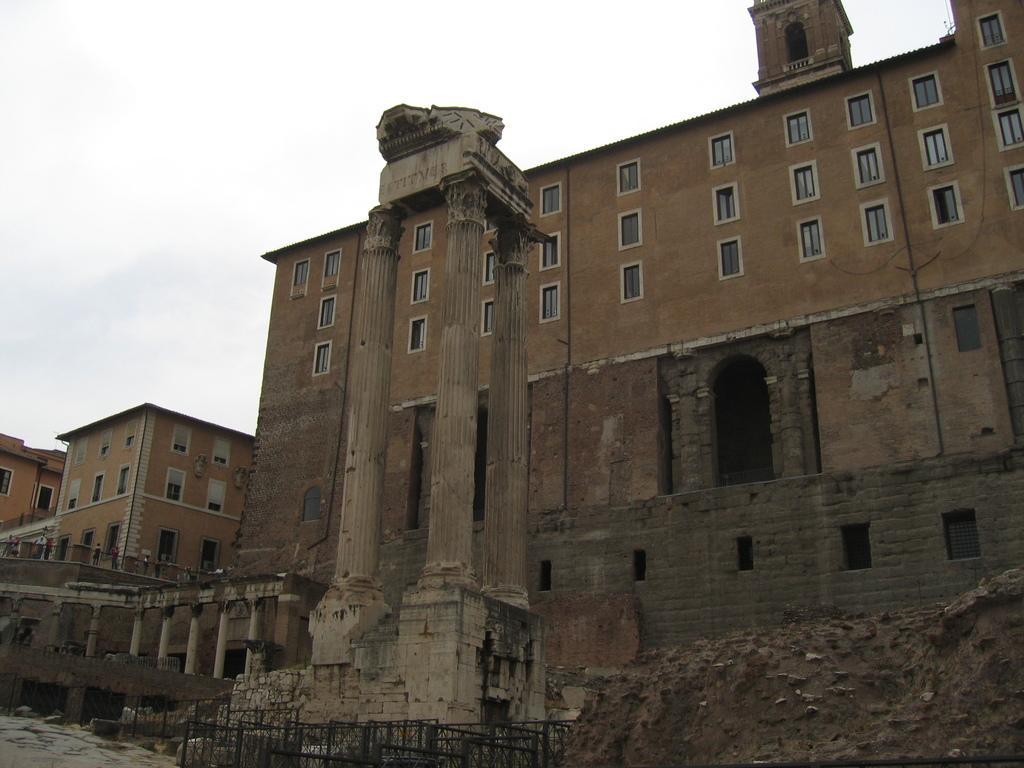Could you give a brief overview of what you see in this image? In the center of the image we can see buildings, pillars, wall, fencing and some persons. At the bottom of the image we can see water, bridge, grills, rocks. At the top of the image there is a sky. 